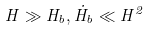Convert formula to latex. <formula><loc_0><loc_0><loc_500><loc_500>H \gg H _ { b } , \dot { H } _ { b } \ll H ^ { 2 }</formula> 